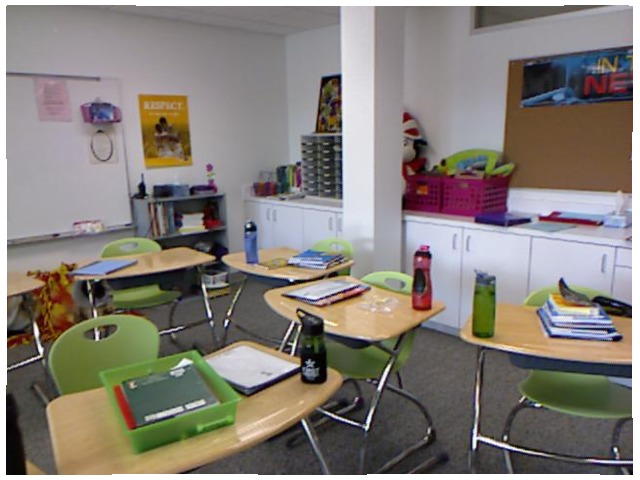<image>
Is the chair under the table? Yes. The chair is positioned underneath the table, with the table above it in the vertical space. Is there a chair on the table? No. The chair is not positioned on the table. They may be near each other, but the chair is not supported by or resting on top of the table. Is there a bottle on the desk? No. The bottle is not positioned on the desk. They may be near each other, but the bottle is not supported by or resting on top of the desk. Where is the stuffed cat in relation to the white column? Is it behind the white column? Yes. From this viewpoint, the stuffed cat is positioned behind the white column, with the white column partially or fully occluding the stuffed cat. Is the green bottle to the right of the red bottle? Yes. From this viewpoint, the green bottle is positioned to the right side relative to the red bottle. Where is the chair in relation to the table? Is it to the left of the table? No. The chair is not to the left of the table. From this viewpoint, they have a different horizontal relationship. Where is the notebook in relation to the bucket? Is it in the bucket? Yes. The notebook is contained within or inside the bucket, showing a containment relationship. 